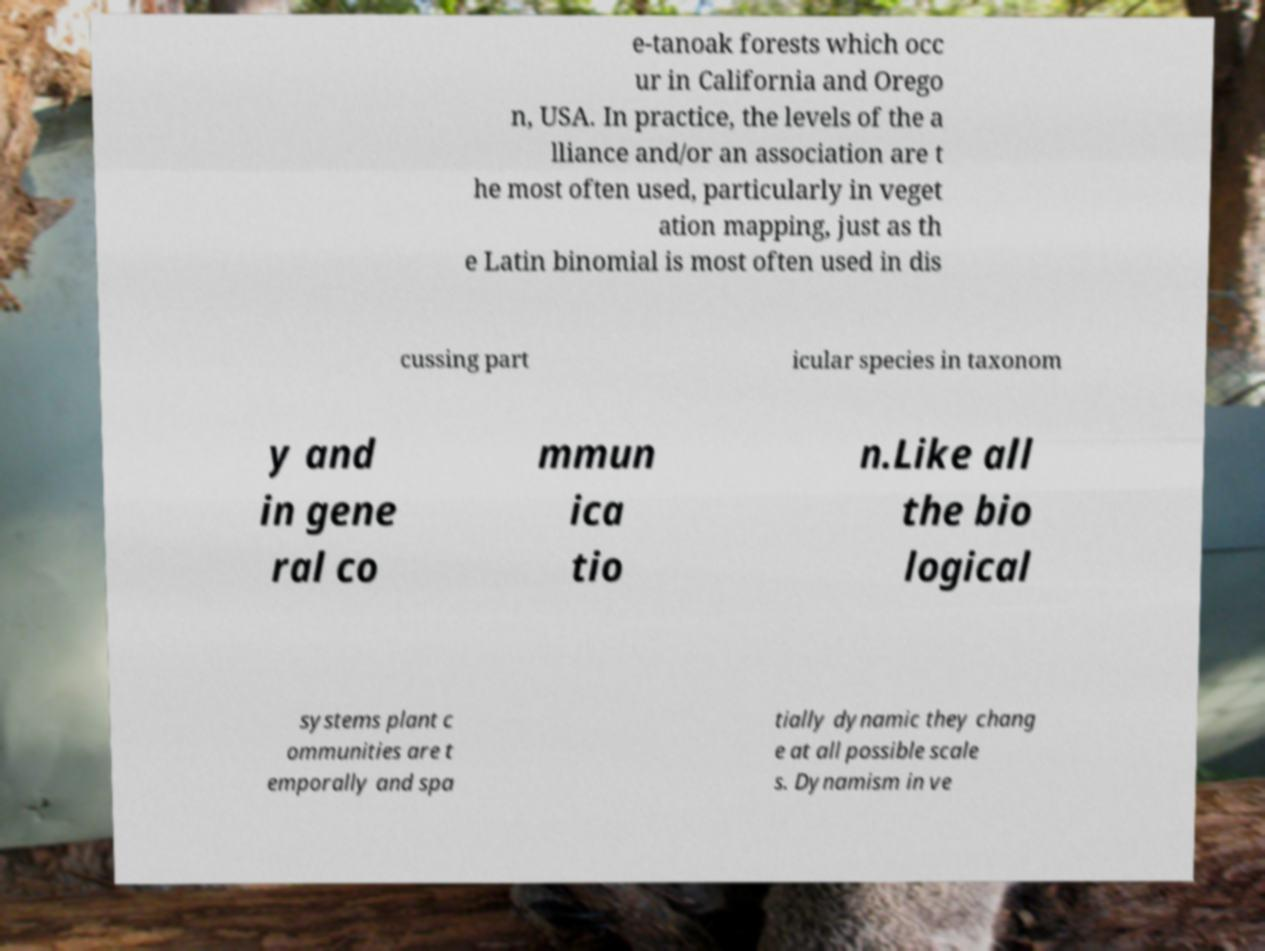Could you assist in decoding the text presented in this image and type it out clearly? e-tanoak forests which occ ur in California and Orego n, USA. In practice, the levels of the a lliance and/or an association are t he most often used, particularly in veget ation mapping, just as th e Latin binomial is most often used in dis cussing part icular species in taxonom y and in gene ral co mmun ica tio n.Like all the bio logical systems plant c ommunities are t emporally and spa tially dynamic they chang e at all possible scale s. Dynamism in ve 